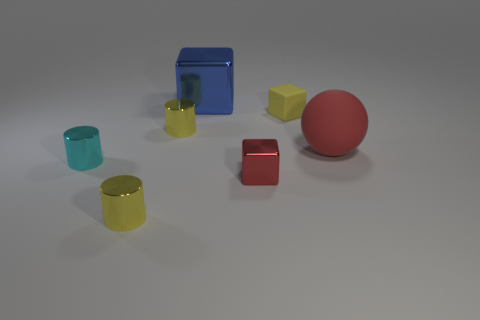Do the tiny yellow block and the yellow cylinder that is behind the red sphere have the same material?
Provide a short and direct response. No. There is a small yellow object in front of the cyan shiny cylinder; what shape is it?
Ensure brevity in your answer.  Cylinder. How many other things are the same material as the small cyan thing?
Offer a very short reply. 4. The ball is what size?
Provide a short and direct response. Large. How many other objects are the same color as the big metal cube?
Keep it short and to the point. 0. There is a tiny metallic object that is in front of the tiny cyan thing and to the left of the big shiny cube; what is its color?
Ensure brevity in your answer.  Yellow. How many large green shiny cylinders are there?
Your response must be concise. 0. Is the small yellow block made of the same material as the tiny red cube?
Provide a short and direct response. No. The large object that is in front of the metal thing behind the tiny yellow metallic cylinder behind the ball is what shape?
Provide a short and direct response. Sphere. Is the material of the big thing behind the tiny matte object the same as the red sphere on the right side of the small red cube?
Provide a succinct answer. No. 